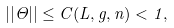Convert formula to latex. <formula><loc_0><loc_0><loc_500><loc_500>| | \Theta | | \leq C ( L , g , n ) < 1 ,</formula> 